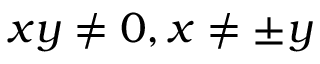<formula> <loc_0><loc_0><loc_500><loc_500>x y \neq 0 , x \neq \pm y</formula> 